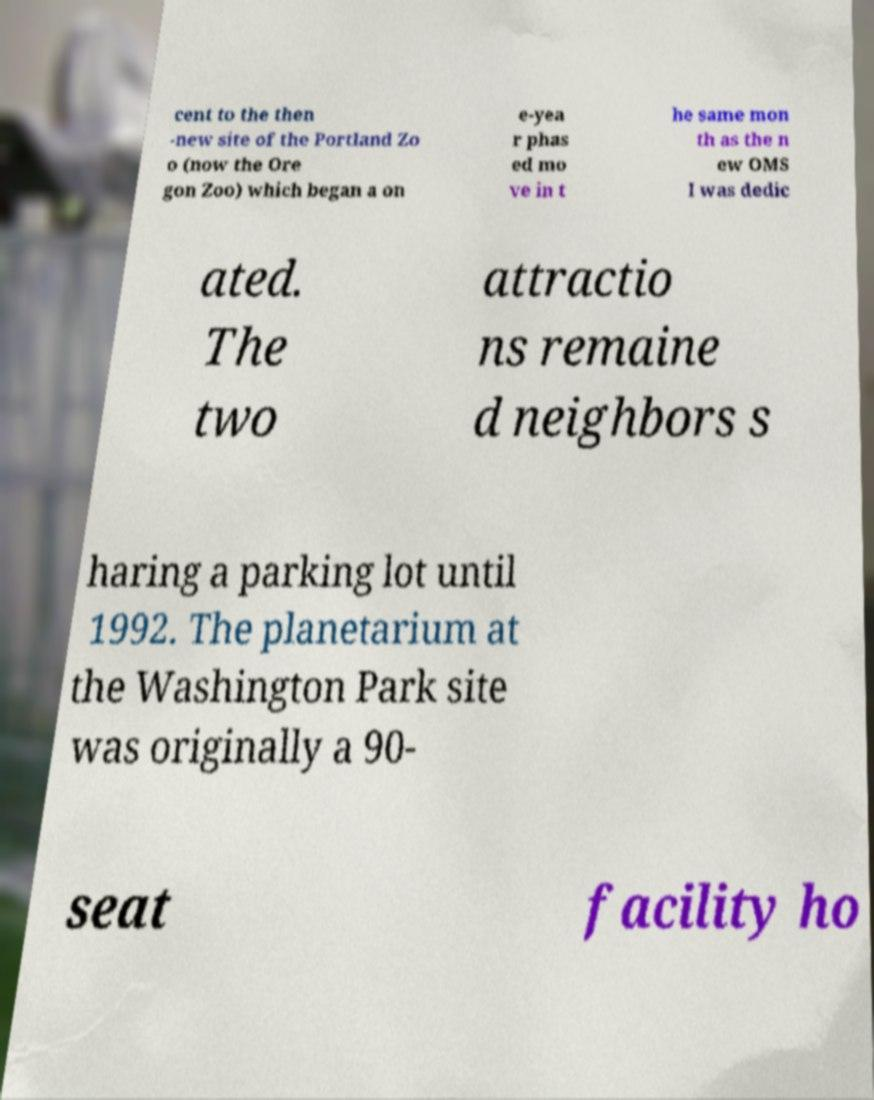For documentation purposes, I need the text within this image transcribed. Could you provide that? cent to the then -new site of the Portland Zo o (now the Ore gon Zoo) which began a on e-yea r phas ed mo ve in t he same mon th as the n ew OMS I was dedic ated. The two attractio ns remaine d neighbors s haring a parking lot until 1992. The planetarium at the Washington Park site was originally a 90- seat facility ho 